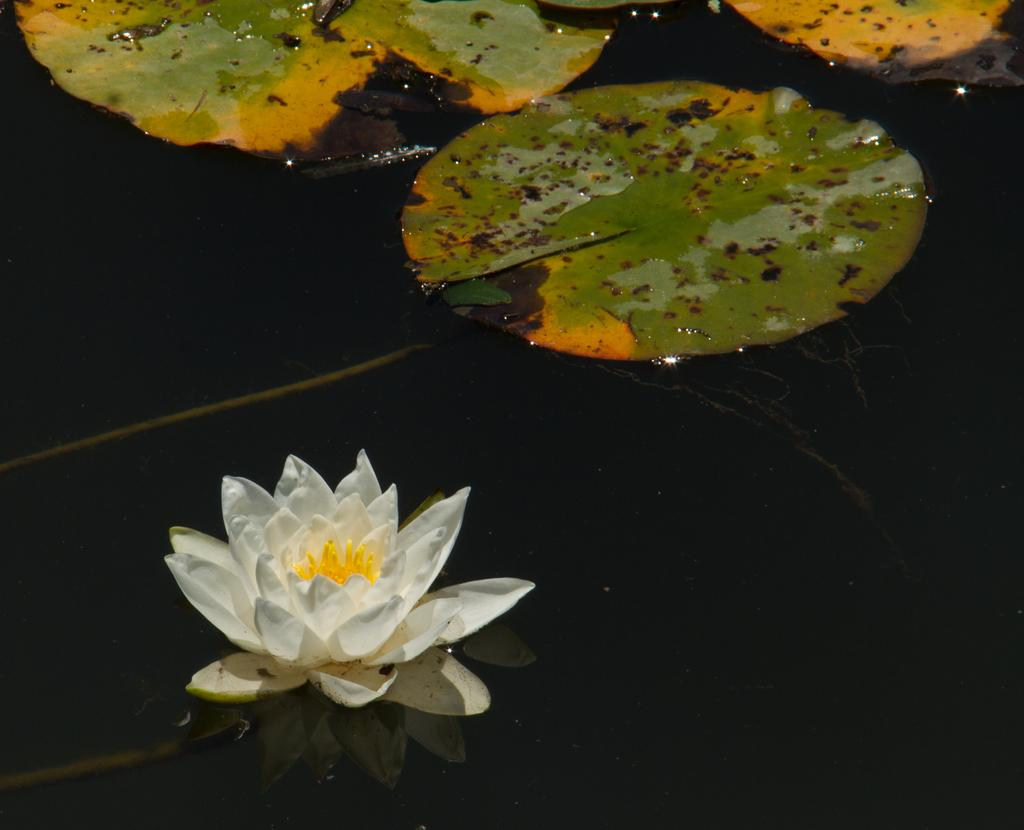What type of plant is in the image? There is a lotus in the image. What else can be seen in the image besides the lotus? There are leaves in the image. Where are the lotus and leaves located? The lotus and leaves are in the water. What type of apparatus is used to extract the mine in the image? There is no apparatus or mine present in the image; it features a lotus and leaves in the water. 